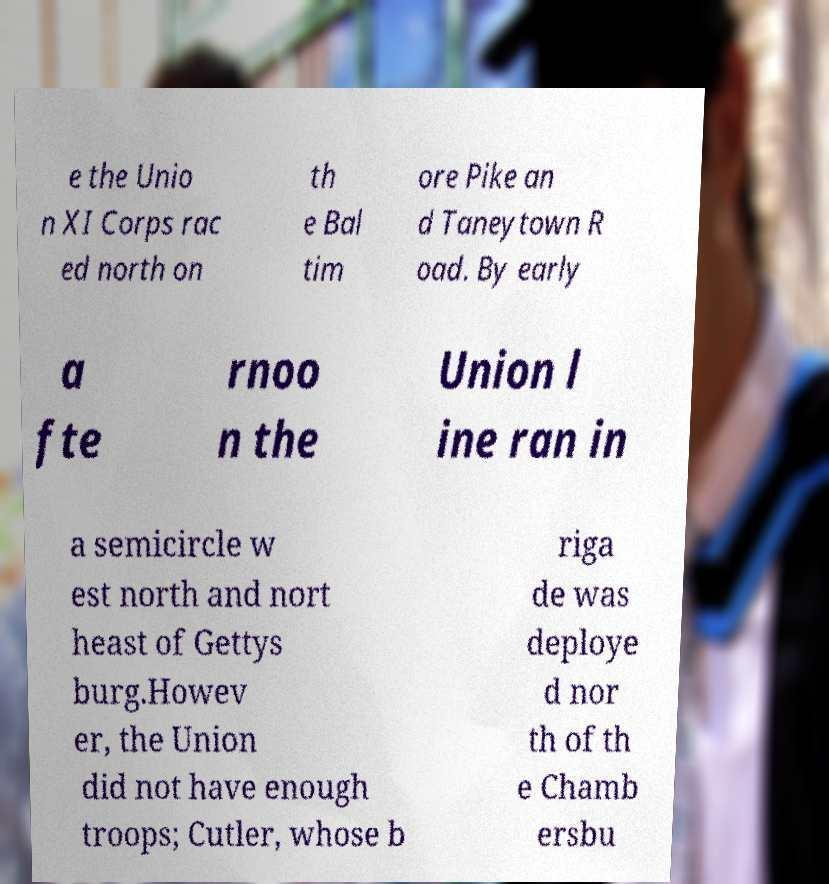For documentation purposes, I need the text within this image transcribed. Could you provide that? e the Unio n XI Corps rac ed north on th e Bal tim ore Pike an d Taneytown R oad. By early a fte rnoo n the Union l ine ran in a semicircle w est north and nort heast of Gettys burg.Howev er, the Union did not have enough troops; Cutler, whose b riga de was deploye d nor th of th e Chamb ersbu 